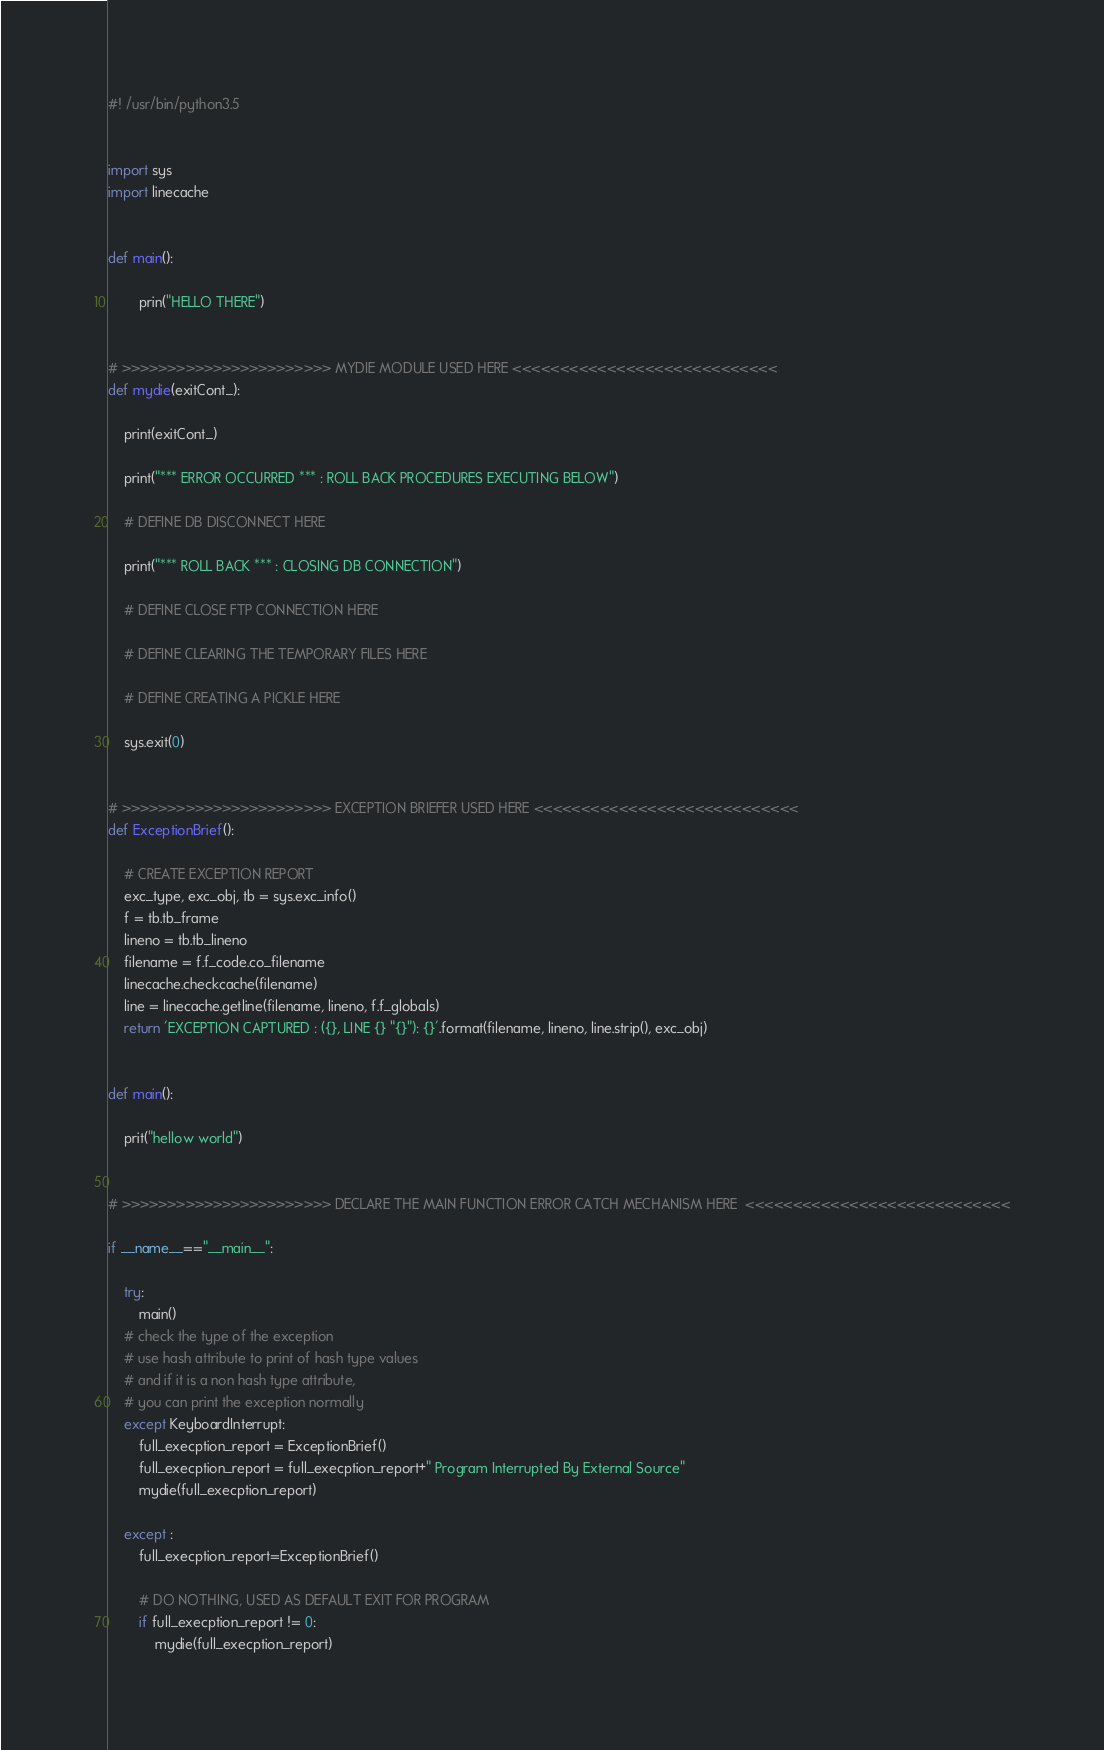Convert code to text. <code><loc_0><loc_0><loc_500><loc_500><_Python_>#! /usr/bin/python3.5


import sys
import linecache


def main():

        prin("HELLO THERE")


# >>>>>>>>>>>>>>>>>>>>>>> MYDIE MODULE USED HERE <<<<<<<<<<<<<<<<<<<<<<<<<<<<
def mydie(exitCont_):

    print(exitCont_)

    print("*** ERROR OCCURRED *** : ROLL BACK PROCEDURES EXECUTING BELOW")

    # DEFINE DB DISCONNECT HERE

    print("*** ROLL BACK *** : CLOSING DB CONNECTION")

    # DEFINE CLOSE FTP CONNECTION HERE

    # DEFINE CLEARING THE TEMPORARY FILES HERE

    # DEFINE CREATING A PICKLE HERE

    sys.exit(0)


# >>>>>>>>>>>>>>>>>>>>>>> EXCEPTION BRIEFER USED HERE <<<<<<<<<<<<<<<<<<<<<<<<<<<<
def ExceptionBrief():

    # CREATE EXCEPTION REPORT
    exc_type, exc_obj, tb = sys.exc_info()
    f = tb.tb_frame
    lineno = tb.tb_lineno
    filename = f.f_code.co_filename
    linecache.checkcache(filename)
    line = linecache.getline(filename, lineno, f.f_globals)
    return 'EXCEPTION CAPTURED : ({}, LINE {} "{}"): {}'.format(filename, lineno, line.strip(), exc_obj)


def main():

    prit("hellow world")


# >>>>>>>>>>>>>>>>>>>>>>> DECLARE THE MAIN FUNCTION ERROR CATCH MECHANISM HERE  <<<<<<<<<<<<<<<<<<<<<<<<<<<<

if __name__=="__main__":

    try:
        main()
    # check the type of the exception
    # use hash attribute to print of hash type values
    # and if it is a non hash type attribute,
    # you can print the exception normally
    except KeyboardInterrupt:
        full_execption_report = ExceptionBrief()
        full_execption_report = full_execption_report+" Program Interrupted By External Source"
        mydie(full_execption_report)

    except :
        full_execption_report=ExceptionBrief()

        # DO NOTHING, USED AS DEFAULT EXIT FOR PROGRAM
        if full_execption_report != 0:
            mydie(full_execption_report)</code> 